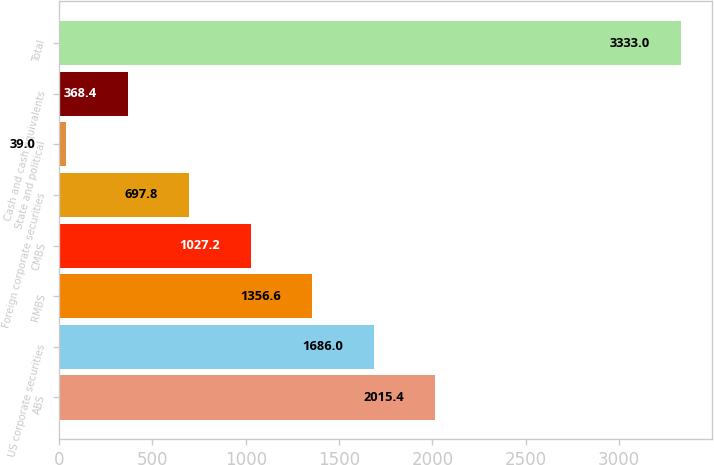Convert chart. <chart><loc_0><loc_0><loc_500><loc_500><bar_chart><fcel>ABS<fcel>US corporate securities<fcel>RMBS<fcel>CMBS<fcel>Foreign corporate securities<fcel>State and political<fcel>Cash and cash equivalents<fcel>Total<nl><fcel>2015.4<fcel>1686<fcel>1356.6<fcel>1027.2<fcel>697.8<fcel>39<fcel>368.4<fcel>3333<nl></chart> 